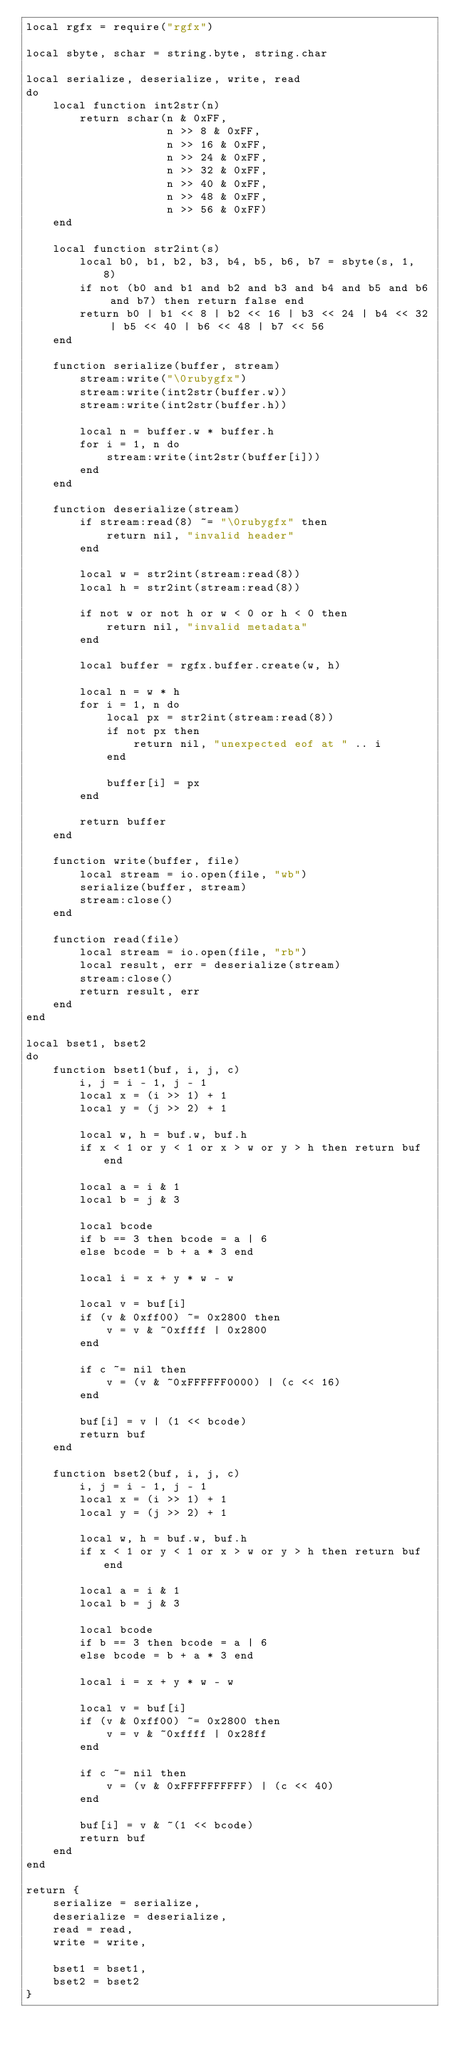Convert code to text. <code><loc_0><loc_0><loc_500><loc_500><_Lua_>local rgfx = require("rgfx")

local sbyte, schar = string.byte, string.char

local serialize, deserialize, write, read
do
    local function int2str(n)
        return schar(n & 0xFF, 
                     n >> 8 & 0xFF, 
                     n >> 16 & 0xFF, 
                     n >> 24 & 0xFF, 
                     n >> 32 & 0xFF, 
                     n >> 40 & 0xFF, 
                     n >> 48 & 0xFF,
                     n >> 56 & 0xFF)
    end

    local function str2int(s)
        local b0, b1, b2, b3, b4, b5, b6, b7 = sbyte(s, 1, 8)
        if not (b0 and b1 and b2 and b3 and b4 and b5 and b6 and b7) then return false end
        return b0 | b1 << 8 | b2 << 16 | b3 << 24 | b4 << 32 | b5 << 40 | b6 << 48 | b7 << 56
    end

    function serialize(buffer, stream)
        stream:write("\0rubygfx")
        stream:write(int2str(buffer.w))
        stream:write(int2str(buffer.h))

        local n = buffer.w * buffer.h
        for i = 1, n do
            stream:write(int2str(buffer[i]))
        end
    end

    function deserialize(stream)
        if stream:read(8) ~= "\0rubygfx" then
            return nil, "invalid header"
        end

        local w = str2int(stream:read(8))
        local h = str2int(stream:read(8))

        if not w or not h or w < 0 or h < 0 then
            return nil, "invalid metadata"
        end

        local buffer = rgfx.buffer.create(w, h)

        local n = w * h
        for i = 1, n do
            local px = str2int(stream:read(8))
            if not px then
                return nil, "unexpected eof at " .. i
            end

            buffer[i] = px 
        end

        return buffer
    end

    function write(buffer, file)
        local stream = io.open(file, "wb")
        serialize(buffer, stream)
        stream:close()
    end

    function read(file)
        local stream = io.open(file, "rb")
        local result, err = deserialize(stream)
        stream:close()
        return result, err
    end
end

local bset1, bset2
do
    function bset1(buf, i, j, c)
        i, j = i - 1, j - 1
        local x = (i >> 1) + 1
        local y = (j >> 2) + 1

        local w, h = buf.w, buf.h
        if x < 1 or y < 1 or x > w or y > h then return buf end

        local a = i & 1
        local b = j & 3
        
        local bcode
        if b == 3 then bcode = a | 6
        else bcode = b + a * 3 end 

        local i = x + y * w - w

        local v = buf[i]
        if (v & 0xff00) ~= 0x2800 then
            v = v & ~0xffff | 0x2800
        end

        if c ~= nil then
            v = (v & ~0xFFFFFF0000) | (c << 16)
        end

        buf[i] = v | (1 << bcode)
        return buf
    end

    function bset2(buf, i, j, c)
        i, j = i - 1, j - 1
        local x = (i >> 1) + 1
        local y = (j >> 2) + 1

        local w, h = buf.w, buf.h
        if x < 1 or y < 1 or x > w or y > h then return buf end

        local a = i & 1
        local b = j & 3
        
        local bcode
        if b == 3 then bcode = a | 6
        else bcode = b + a * 3 end 

        local i = x + y * w - w

        local v = buf[i]
        if (v & 0xff00) ~= 0x2800 then
            v = v & ~0xffff | 0x28ff
        end

        if c ~= nil then
            v = (v & 0xFFFFFFFFFF) | (c << 40)
        end

        buf[i] = v & ~(1 << bcode)
        return buf
    end
end

return {
    serialize = serialize,
    deserialize = deserialize,
    read = read,
    write = write,

    bset1 = bset1,
    bset2 = bset2
}</code> 